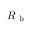Convert formula to latex. <formula><loc_0><loc_0><loc_500><loc_500>R _ { b }</formula> 